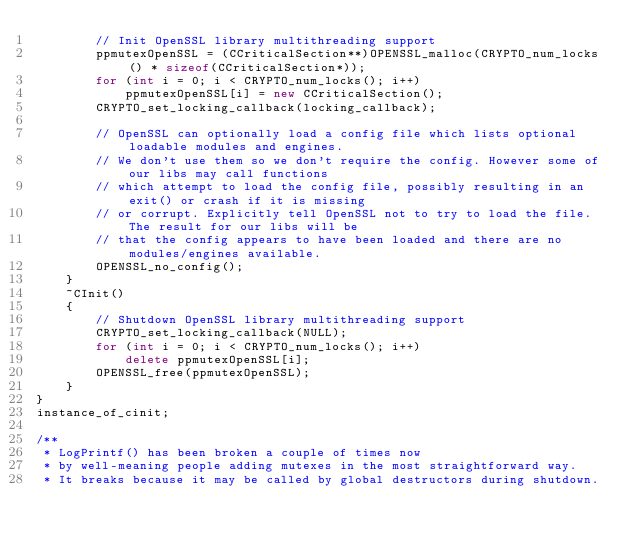Convert code to text. <code><loc_0><loc_0><loc_500><loc_500><_C++_>        // Init OpenSSL library multithreading support
        ppmutexOpenSSL = (CCriticalSection**)OPENSSL_malloc(CRYPTO_num_locks() * sizeof(CCriticalSection*));
        for (int i = 0; i < CRYPTO_num_locks(); i++)
            ppmutexOpenSSL[i] = new CCriticalSection();
        CRYPTO_set_locking_callback(locking_callback);

        // OpenSSL can optionally load a config file which lists optional loadable modules and engines.
        // We don't use them so we don't require the config. However some of our libs may call functions
        // which attempt to load the config file, possibly resulting in an exit() or crash if it is missing
        // or corrupt. Explicitly tell OpenSSL not to try to load the file. The result for our libs will be
        // that the config appears to have been loaded and there are no modules/engines available.
        OPENSSL_no_config();
    }
    ~CInit()
    {
        // Shutdown OpenSSL library multithreading support
        CRYPTO_set_locking_callback(NULL);
        for (int i = 0; i < CRYPTO_num_locks(); i++)
            delete ppmutexOpenSSL[i];
        OPENSSL_free(ppmutexOpenSSL);
    }
}
instance_of_cinit;

/**
 * LogPrintf() has been broken a couple of times now
 * by well-meaning people adding mutexes in the most straightforward way.
 * It breaks because it may be called by global destructors during shutdown.</code> 